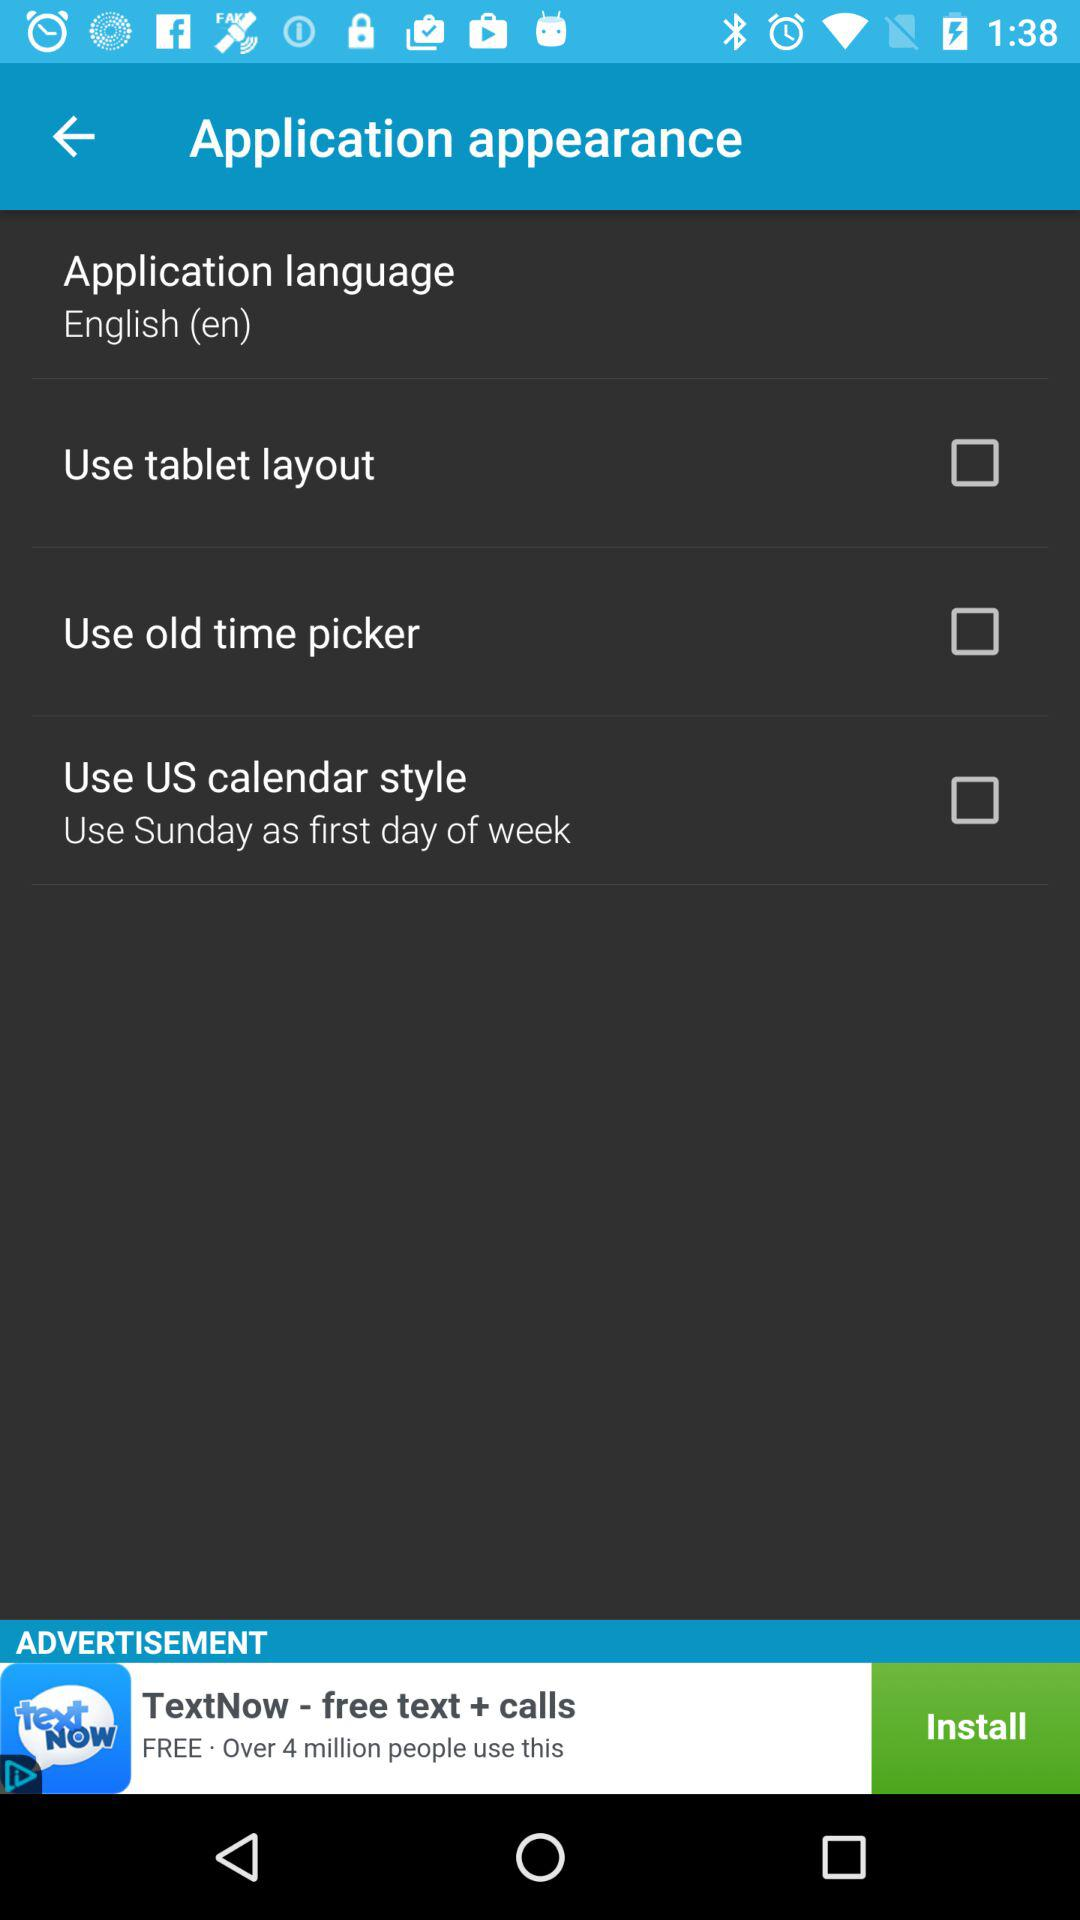What is the application language? The application language is English. 